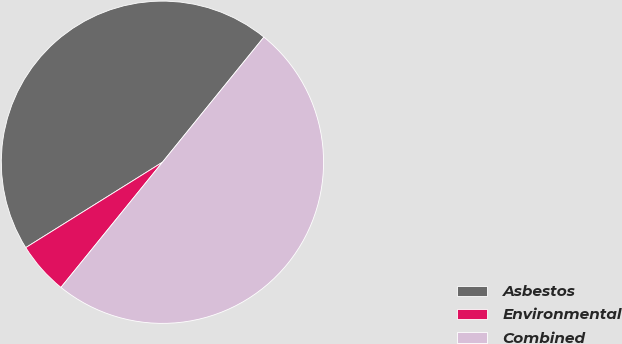Convert chart. <chart><loc_0><loc_0><loc_500><loc_500><pie_chart><fcel>Asbestos<fcel>Environmental<fcel>Combined<nl><fcel>44.73%<fcel>5.27%<fcel>50.0%<nl></chart> 